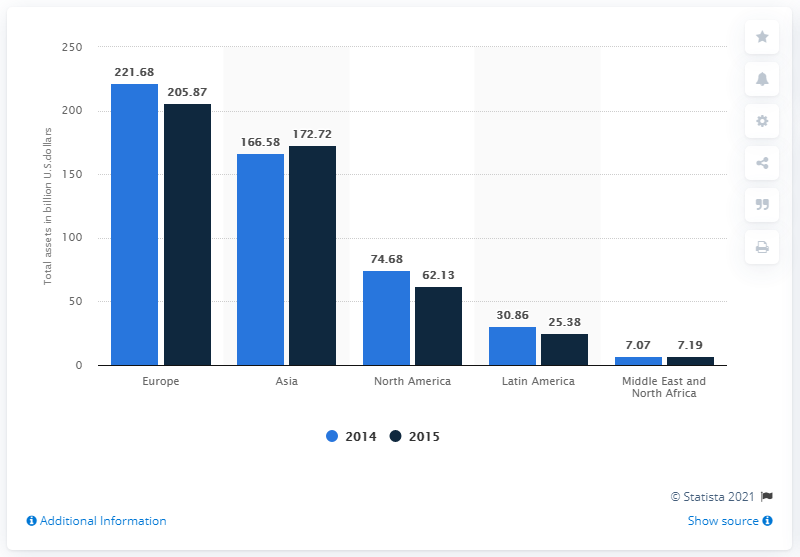Identify some key points in this picture. In 2015, the total assets of the retail banking and wealth management sector of HSBC bank in North America were $62.13 billion. 